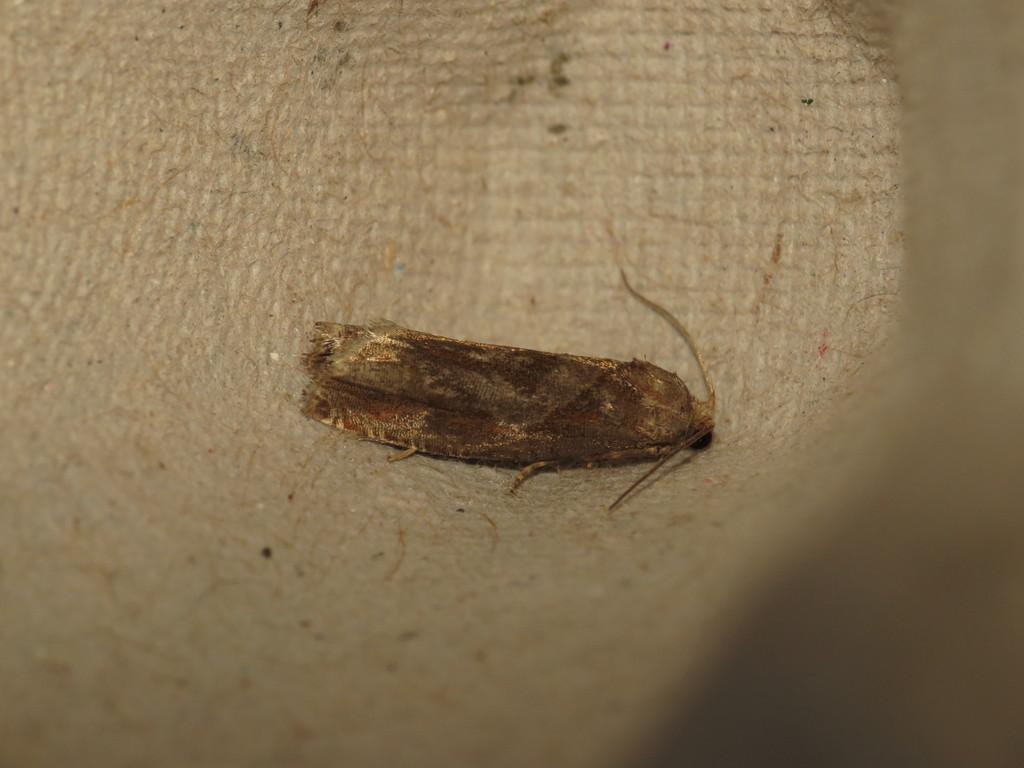Please provide a concise description of this image. In this image we can see an insect on the surface. This part of the image is blurred. 